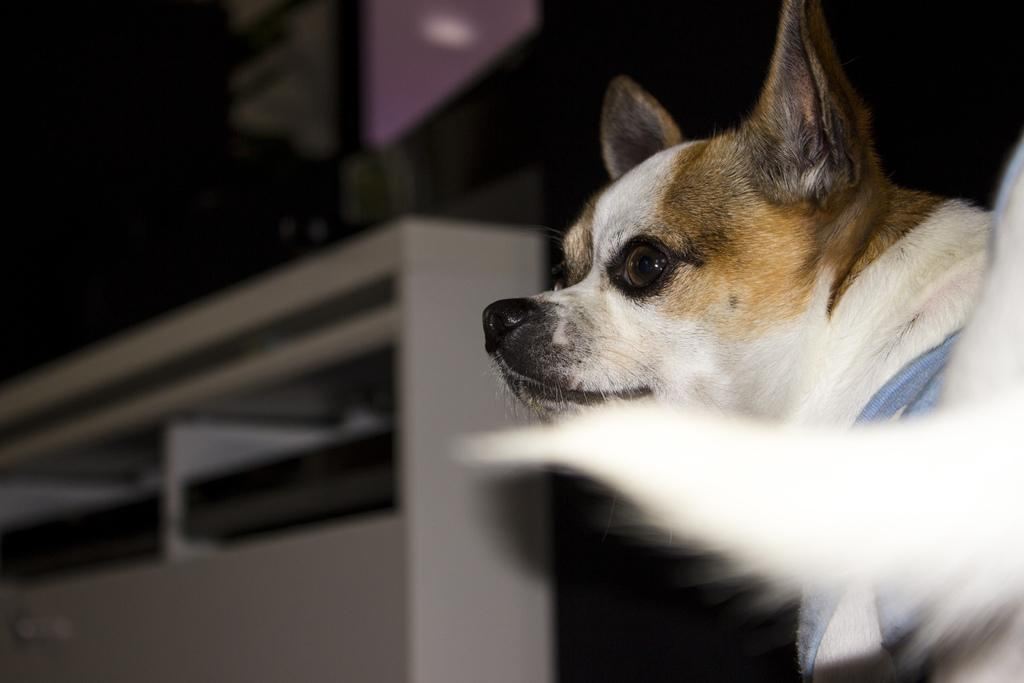What animal can be seen in the image? There is a dog in the image. Where is the dog located in the image? The dog is on the right side of the image. What direction is the dog looking in? The dog is looking at the left side. How would you describe the background of the image? The backdrop of the image is dark and blurred. Can you see the dog smiling in the image? There is no indication of the dog's facial expression in the image, so it cannot be determined if the dog is smiling. 